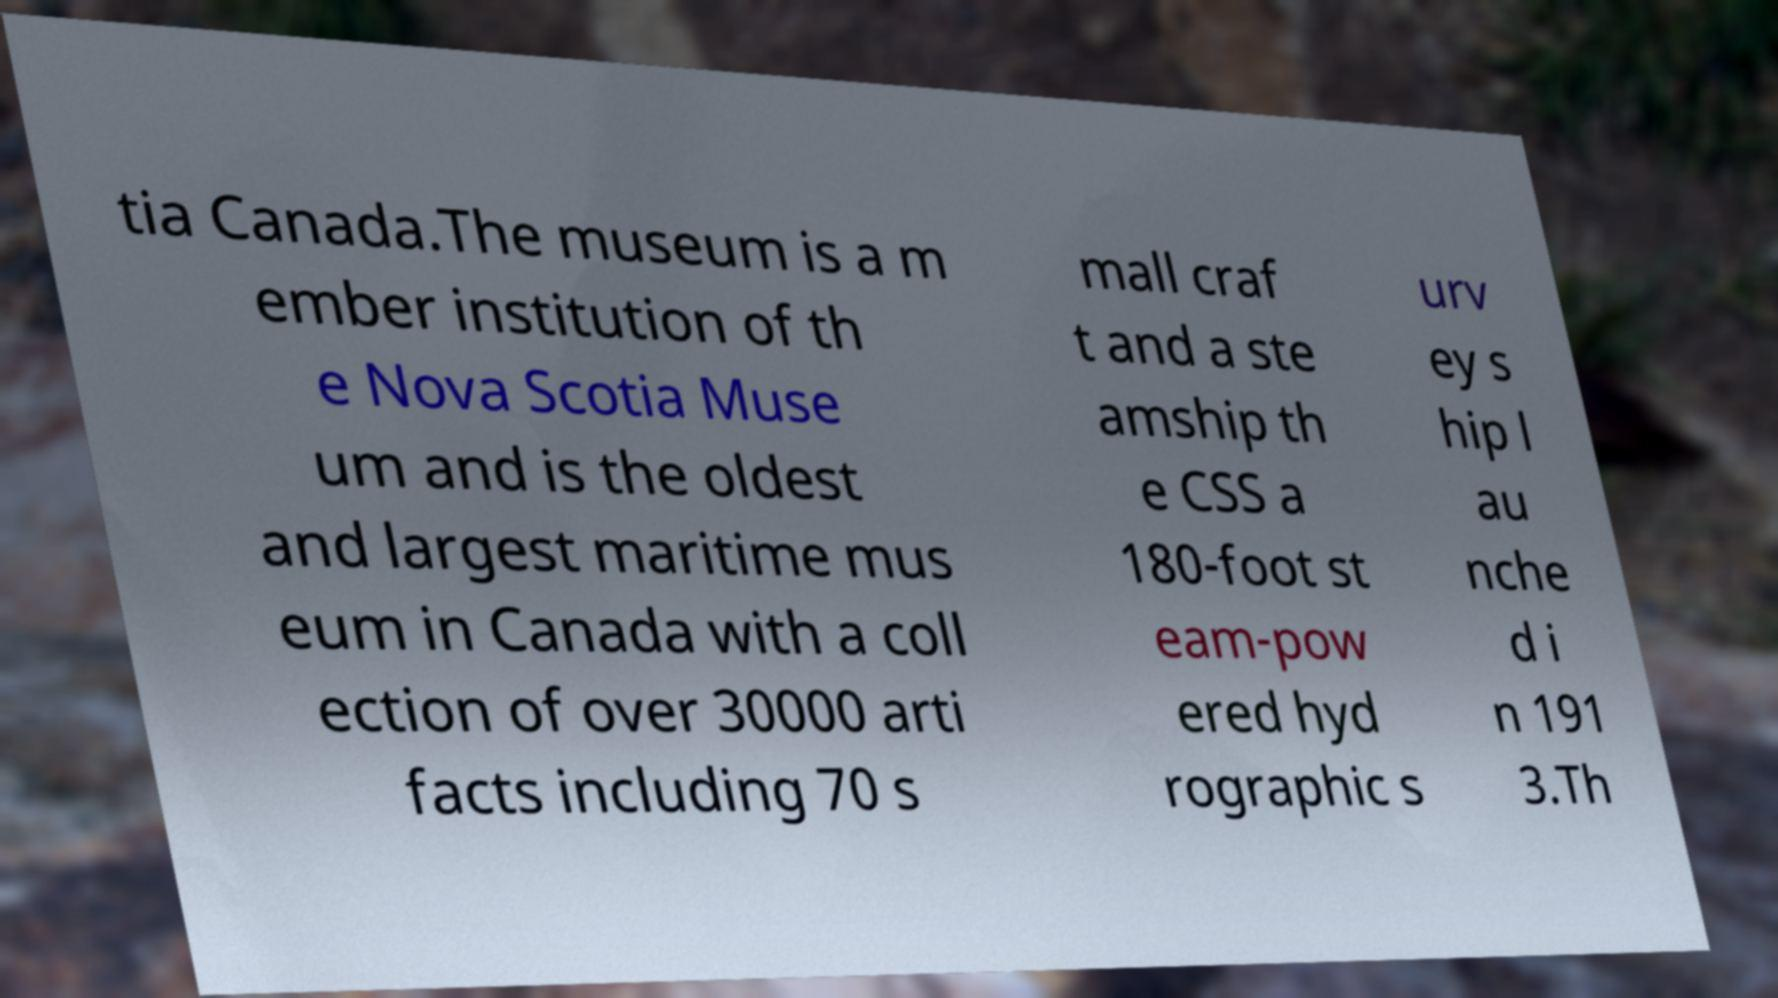Please read and relay the text visible in this image. What does it say? tia Canada.The museum is a m ember institution of th e Nova Scotia Muse um and is the oldest and largest maritime mus eum in Canada with a coll ection of over 30000 arti facts including 70 s mall craf t and a ste amship th e CSS a 180-foot st eam-pow ered hyd rographic s urv ey s hip l au nche d i n 191 3.Th 